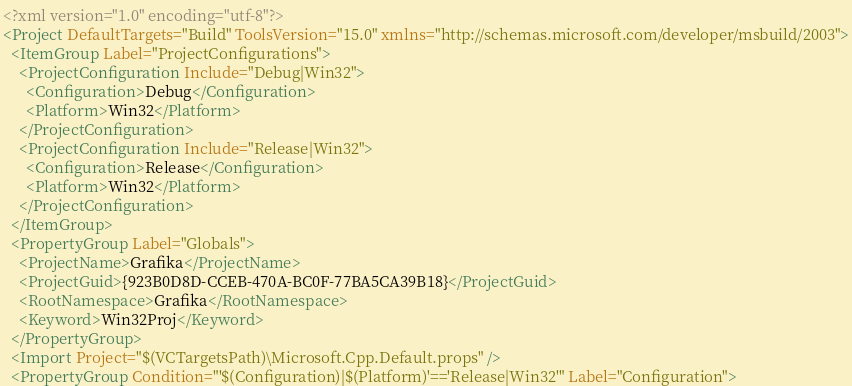<code> <loc_0><loc_0><loc_500><loc_500><_XML_><?xml version="1.0" encoding="utf-8"?>
<Project DefaultTargets="Build" ToolsVersion="15.0" xmlns="http://schemas.microsoft.com/developer/msbuild/2003">
  <ItemGroup Label="ProjectConfigurations">
    <ProjectConfiguration Include="Debug|Win32">
      <Configuration>Debug</Configuration>
      <Platform>Win32</Platform>
    </ProjectConfiguration>
    <ProjectConfiguration Include="Release|Win32">
      <Configuration>Release</Configuration>
      <Platform>Win32</Platform>
    </ProjectConfiguration>
  </ItemGroup>
  <PropertyGroup Label="Globals">
    <ProjectName>Grafika</ProjectName>
    <ProjectGuid>{923B0D8D-CCEB-470A-BC0F-77BA5CA39B18}</ProjectGuid>
    <RootNamespace>Grafika</RootNamespace>
    <Keyword>Win32Proj</Keyword>
  </PropertyGroup>
  <Import Project="$(VCTargetsPath)\Microsoft.Cpp.Default.props" />
  <PropertyGroup Condition="'$(Configuration)|$(Platform)'=='Release|Win32'" Label="Configuration"></code> 